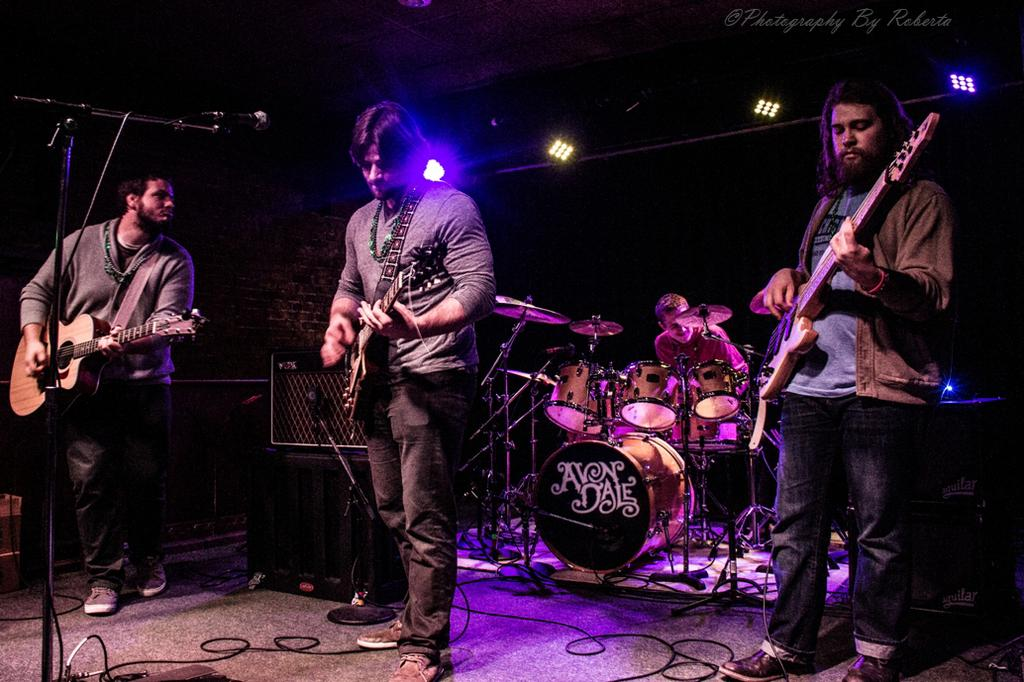How many people are on stage in the image? There are four people on stage in the image. What are three of the people holding? Three of the people are holding guitars. What instrument is being played by the person in the background? One person is playing drums in the background. What type of print or map is visible on the stage? There is no print or map visible on the stage in the image. What is the opinion of the drummer about the performance? The image does not provide any information about the drummer's opinion on the performance. 